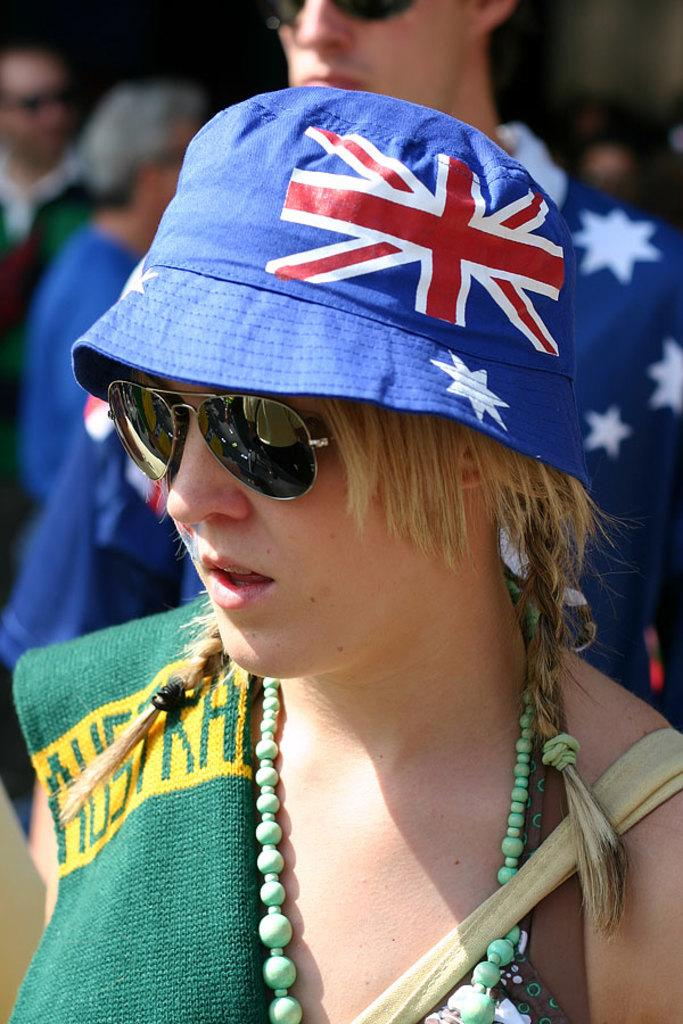What is the woman in the image wearing on her head? The woman is wearing a cap. What type of eyewear is the woman wearing in the image? The woman is wearing goggles. What type of clothing is the woman wearing in the image? The woman is wearing a dress. What type of accessory is the woman wearing in the image? The woman is wearing a necklace. Can you describe the people in the background of the image? There are people standing in the background of the image. What is the smell of the development in the image? There is no mention of development or any smell in the image; it features a woman wearing a cap, goggles, a dress, and a necklace, with people standing in the background. 